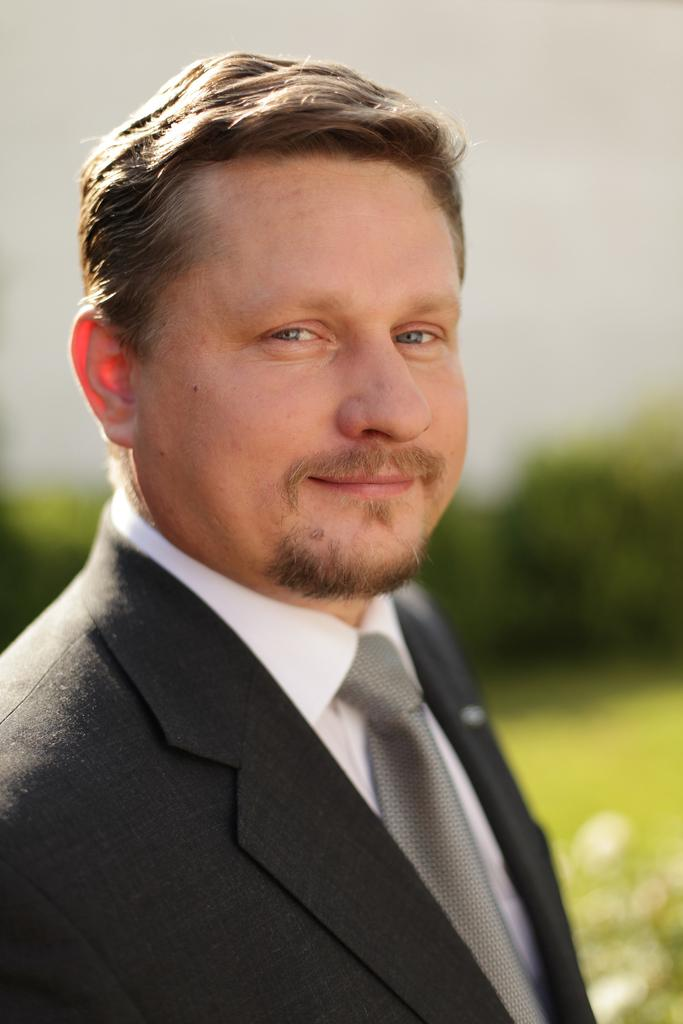What is the main subject of the image? The main subject of the image is a man. What is the man wearing on his upper body? The man is wearing a white shirt and a black coat. Is there any accessory visible on the man? Yes, the man is wearing a tie. What is the man's facial expression in the image? The man is smiling in the image. Can you describe the background of the image? The background of the image is blurry. What type of beggar is present in the image? There is no beggar present in the image; it features a man wearing a white shirt, black coat, and tie, and smiling. What type of queen is depicted in the image? There is no queen depicted in the image; it features a man wearing a white shirt, black coat, and tie, and smiling. 